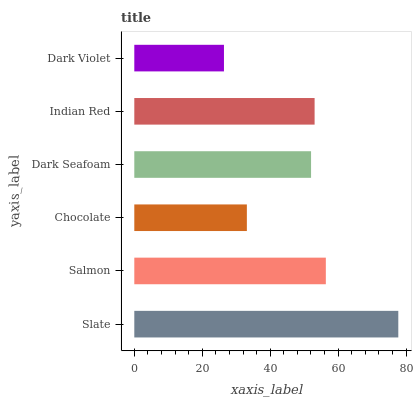Is Dark Violet the minimum?
Answer yes or no. Yes. Is Slate the maximum?
Answer yes or no. Yes. Is Salmon the minimum?
Answer yes or no. No. Is Salmon the maximum?
Answer yes or no. No. Is Slate greater than Salmon?
Answer yes or no. Yes. Is Salmon less than Slate?
Answer yes or no. Yes. Is Salmon greater than Slate?
Answer yes or no. No. Is Slate less than Salmon?
Answer yes or no. No. Is Indian Red the high median?
Answer yes or no. Yes. Is Dark Seafoam the low median?
Answer yes or no. Yes. Is Dark Violet the high median?
Answer yes or no. No. Is Slate the low median?
Answer yes or no. No. 